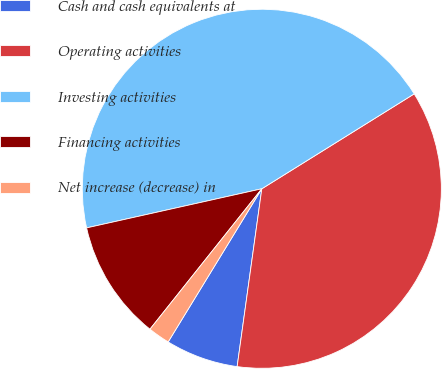Convert chart. <chart><loc_0><loc_0><loc_500><loc_500><pie_chart><fcel>Cash and cash equivalents at<fcel>Operating activities<fcel>Investing activities<fcel>Financing activities<fcel>Net increase (decrease) in<nl><fcel>6.54%<fcel>36.06%<fcel>44.63%<fcel>10.8%<fcel>1.97%<nl></chart> 